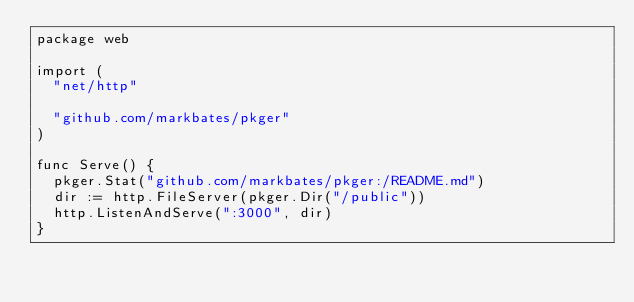<code> <loc_0><loc_0><loc_500><loc_500><_Go_>package web

import (
	"net/http"

	"github.com/markbates/pkger"
)

func Serve() {
	pkger.Stat("github.com/markbates/pkger:/README.md")
	dir := http.FileServer(pkger.Dir("/public"))
	http.ListenAndServe(":3000", dir)
}
</code> 